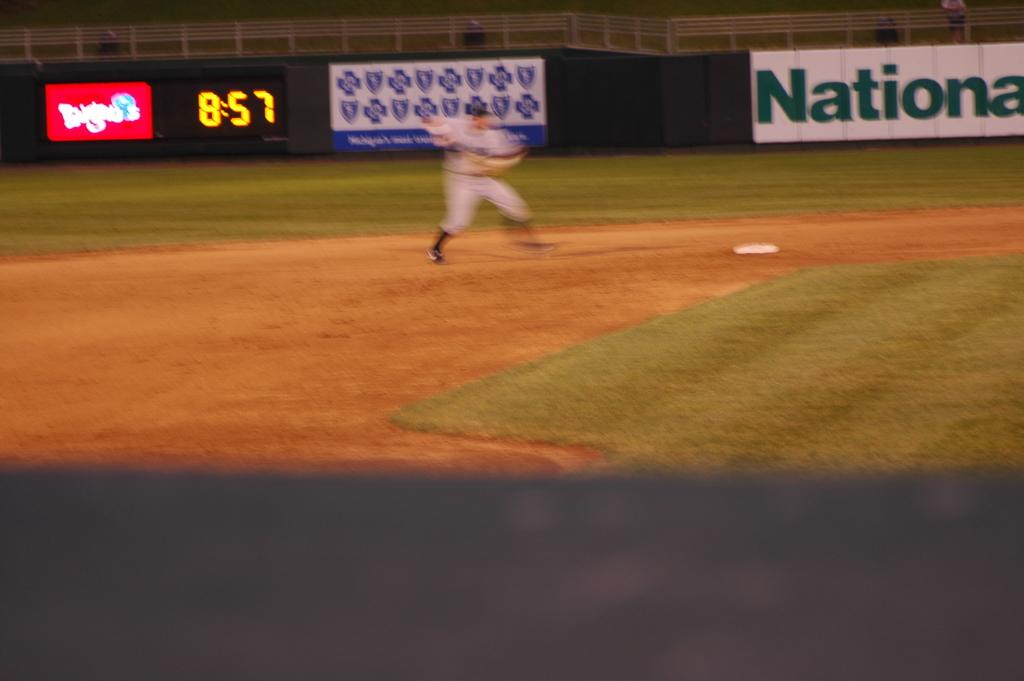<image>
Give a short and clear explanation of the subsequent image. At 8:57 the short stop attempts to throw a runner out. 